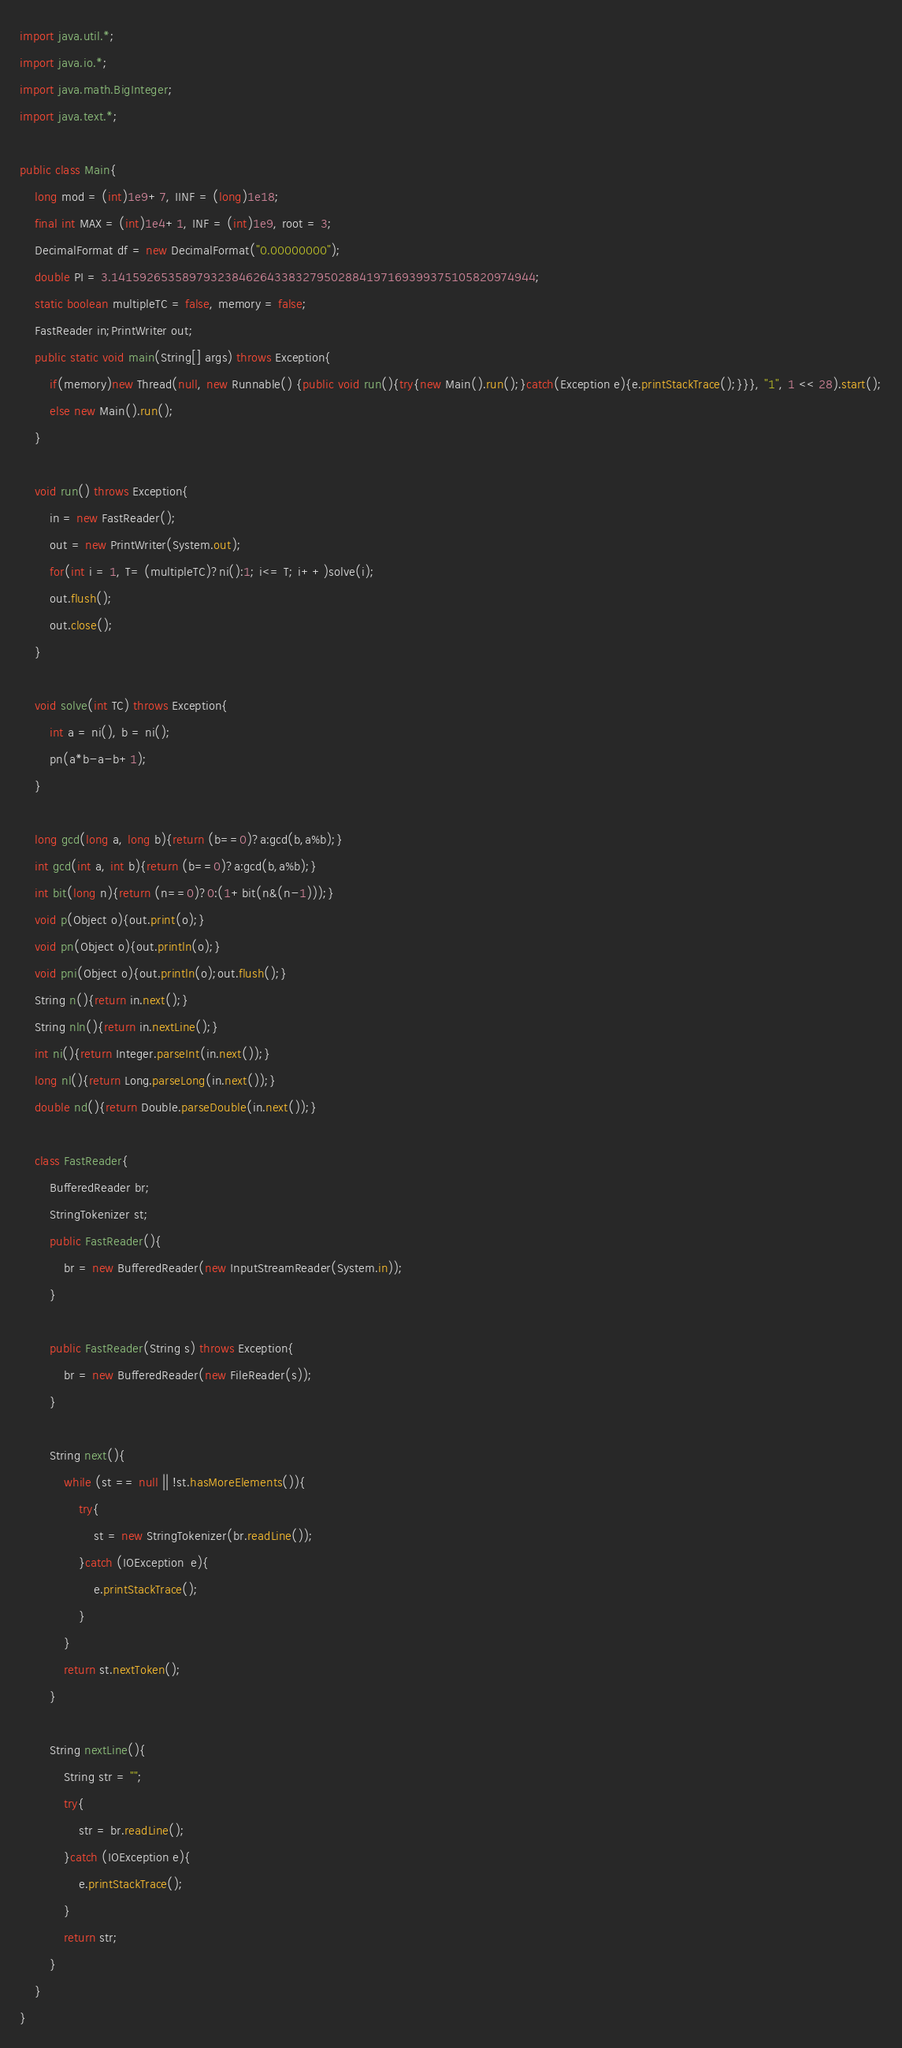Convert code to text. <code><loc_0><loc_0><loc_500><loc_500><_Java_>import java.util.*;
import java.io.*; 
import java.math.BigInteger;
import java.text.*;

public class Main{
    long mod = (int)1e9+7, IINF = (long)1e18;
    final int MAX = (int)1e4+1, INF = (int)1e9, root = 3;
    DecimalFormat df = new DecimalFormat("0.00000000");
    double PI = 3.141592653589793238462643383279502884197169399375105820974944;
    static boolean multipleTC = false, memory = false;
    FastReader in;PrintWriter out;
    public static void main(String[] args) throws Exception{
        if(memory)new Thread(null, new Runnable() {public void run(){try{new Main().run();}catch(Exception e){e.printStackTrace();}}}, "1", 1 << 28).start();
        else new Main().run();
    }

    void run() throws Exception{
        in = new FastReader();
        out = new PrintWriter(System.out);
        for(int i = 1, T= (multipleTC)?ni():1; i<= T; i++)solve(i);
        out.flush();
        out.close();
    }
    
    void solve(int TC) throws Exception{
        int a = ni(), b = ni();
        pn(a*b-a-b+1);
    }
    
    long gcd(long a, long b){return (b==0)?a:gcd(b,a%b);}
    int gcd(int a, int b){return (b==0)?a:gcd(b,a%b);}
    int bit(long n){return (n==0)?0:(1+bit(n&(n-1)));}
    void p(Object o){out.print(o);}
    void pn(Object o){out.println(o);}
    void pni(Object o){out.println(o);out.flush();}
    String n(){return in.next();}
    String nln(){return in.nextLine();}
    int ni(){return Integer.parseInt(in.next());}
    long nl(){return Long.parseLong(in.next());}
    double nd(){return Double.parseDouble(in.next());}

    class FastReader{
        BufferedReader br;
        StringTokenizer st;
        public FastReader(){
            br = new BufferedReader(new InputStreamReader(System.in));
        }

        public FastReader(String s) throws Exception{
            br = new BufferedReader(new FileReader(s));
        }

        String next(){
            while (st == null || !st.hasMoreElements()){
                try{
                    st = new StringTokenizer(br.readLine());
                }catch (IOException  e){
                    e.printStackTrace();
                }
            }
            return st.nextToken();
        }

        String nextLine(){
            String str = "";
            try{    
                str = br.readLine();
            }catch (IOException e){
                e.printStackTrace();
            }   
            return str;
        }
    }
}   </code> 